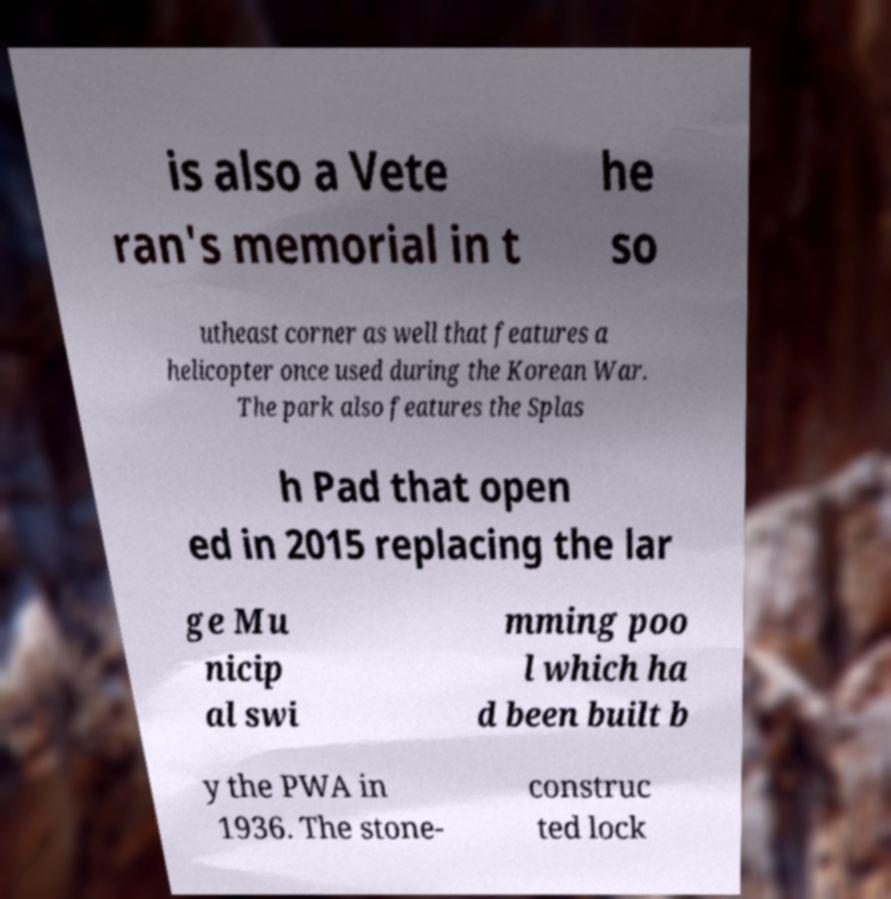There's text embedded in this image that I need extracted. Can you transcribe it verbatim? is also a Vete ran's memorial in t he so utheast corner as well that features a helicopter once used during the Korean War. The park also features the Splas h Pad that open ed in 2015 replacing the lar ge Mu nicip al swi mming poo l which ha d been built b y the PWA in 1936. The stone- construc ted lock 